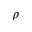<formula> <loc_0><loc_0><loc_500><loc_500>\rho</formula> 